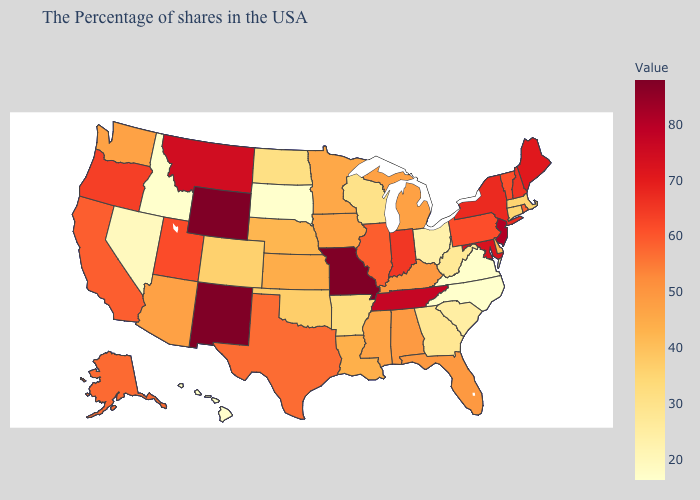Among the states that border Massachusetts , does New Hampshire have the lowest value?
Write a very short answer. No. Which states have the lowest value in the West?
Concise answer only. Idaho, Hawaii. Does Florida have a higher value than New Jersey?
Answer briefly. No. Among the states that border Idaho , does Wyoming have the highest value?
Concise answer only. Yes. Which states have the lowest value in the USA?
Quick response, please. Virginia, North Carolina, South Dakota, Idaho, Hawaii. Does Missouri have the highest value in the MidWest?
Give a very brief answer. Yes. Does Missouri have the highest value in the USA?
Quick response, please. Yes. 